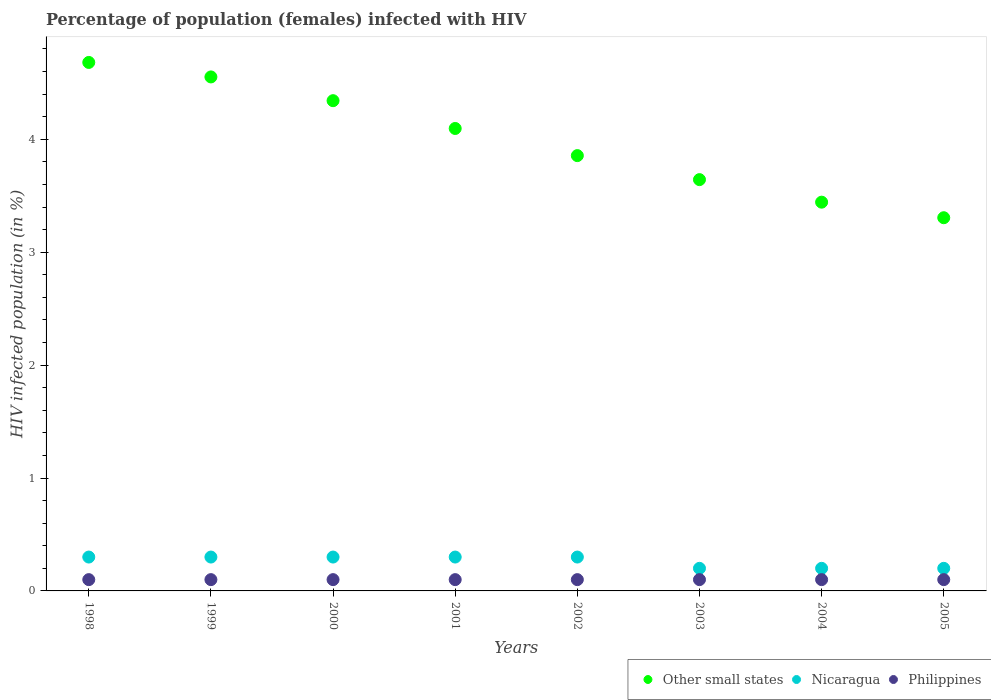Is the number of dotlines equal to the number of legend labels?
Make the answer very short. Yes. What is the percentage of HIV infected female population in Philippines in 2005?
Make the answer very short. 0.1. Across all years, what is the minimum percentage of HIV infected female population in Nicaragua?
Your response must be concise. 0.2. In which year was the percentage of HIV infected female population in Philippines maximum?
Keep it short and to the point. 1998. What is the total percentage of HIV infected female population in Other small states in the graph?
Give a very brief answer. 31.92. What is the difference between the percentage of HIV infected female population in Other small states in 2000 and that in 2003?
Provide a succinct answer. 0.7. What is the difference between the percentage of HIV infected female population in Other small states in 2004 and the percentage of HIV infected female population in Nicaragua in 2003?
Provide a short and direct response. 3.24. What is the average percentage of HIV infected female population in Philippines per year?
Provide a succinct answer. 0.1. In the year 2003, what is the difference between the percentage of HIV infected female population in Philippines and percentage of HIV infected female population in Nicaragua?
Provide a short and direct response. -0.1. What is the ratio of the percentage of HIV infected female population in Nicaragua in 1998 to that in 2003?
Offer a terse response. 1.5. What is the difference between the highest and the second highest percentage of HIV infected female population in Other small states?
Offer a very short reply. 0.13. What is the difference between the highest and the lowest percentage of HIV infected female population in Other small states?
Provide a short and direct response. 1.38. In how many years, is the percentage of HIV infected female population in Nicaragua greater than the average percentage of HIV infected female population in Nicaragua taken over all years?
Ensure brevity in your answer.  5. Is the sum of the percentage of HIV infected female population in Nicaragua in 1998 and 1999 greater than the maximum percentage of HIV infected female population in Philippines across all years?
Offer a terse response. Yes. Is it the case that in every year, the sum of the percentage of HIV infected female population in Philippines and percentage of HIV infected female population in Nicaragua  is greater than the percentage of HIV infected female population in Other small states?
Your answer should be compact. No. Is the percentage of HIV infected female population in Other small states strictly less than the percentage of HIV infected female population in Nicaragua over the years?
Keep it short and to the point. No. What is the difference between two consecutive major ticks on the Y-axis?
Provide a short and direct response. 1. Are the values on the major ticks of Y-axis written in scientific E-notation?
Give a very brief answer. No. Does the graph contain any zero values?
Keep it short and to the point. No. Does the graph contain grids?
Your response must be concise. No. Where does the legend appear in the graph?
Make the answer very short. Bottom right. How many legend labels are there?
Provide a short and direct response. 3. How are the legend labels stacked?
Keep it short and to the point. Horizontal. What is the title of the graph?
Offer a terse response. Percentage of population (females) infected with HIV. What is the label or title of the X-axis?
Keep it short and to the point. Years. What is the label or title of the Y-axis?
Offer a terse response. HIV infected population (in %). What is the HIV infected population (in %) in Other small states in 1998?
Offer a terse response. 4.68. What is the HIV infected population (in %) in Nicaragua in 1998?
Your answer should be very brief. 0.3. What is the HIV infected population (in %) in Other small states in 1999?
Your response must be concise. 4.55. What is the HIV infected population (in %) in Nicaragua in 1999?
Make the answer very short. 0.3. What is the HIV infected population (in %) in Philippines in 1999?
Provide a short and direct response. 0.1. What is the HIV infected population (in %) of Other small states in 2000?
Provide a short and direct response. 4.34. What is the HIV infected population (in %) of Other small states in 2001?
Your answer should be compact. 4.1. What is the HIV infected population (in %) in Other small states in 2002?
Make the answer very short. 3.86. What is the HIV infected population (in %) of Other small states in 2003?
Your answer should be compact. 3.64. What is the HIV infected population (in %) in Nicaragua in 2003?
Make the answer very short. 0.2. What is the HIV infected population (in %) of Philippines in 2003?
Your answer should be compact. 0.1. What is the HIV infected population (in %) of Other small states in 2004?
Ensure brevity in your answer.  3.44. What is the HIV infected population (in %) in Nicaragua in 2004?
Your response must be concise. 0.2. What is the HIV infected population (in %) in Philippines in 2004?
Keep it short and to the point. 0.1. What is the HIV infected population (in %) in Other small states in 2005?
Your answer should be very brief. 3.31. What is the HIV infected population (in %) in Nicaragua in 2005?
Provide a succinct answer. 0.2. Across all years, what is the maximum HIV infected population (in %) of Other small states?
Keep it short and to the point. 4.68. Across all years, what is the maximum HIV infected population (in %) in Nicaragua?
Give a very brief answer. 0.3. Across all years, what is the minimum HIV infected population (in %) in Other small states?
Ensure brevity in your answer.  3.31. What is the total HIV infected population (in %) of Other small states in the graph?
Keep it short and to the point. 31.92. What is the total HIV infected population (in %) in Nicaragua in the graph?
Your response must be concise. 2.1. What is the difference between the HIV infected population (in %) of Other small states in 1998 and that in 1999?
Offer a very short reply. 0.13. What is the difference between the HIV infected population (in %) in Nicaragua in 1998 and that in 1999?
Make the answer very short. 0. What is the difference between the HIV infected population (in %) of Philippines in 1998 and that in 1999?
Give a very brief answer. 0. What is the difference between the HIV infected population (in %) of Other small states in 1998 and that in 2000?
Your response must be concise. 0.34. What is the difference between the HIV infected population (in %) in Philippines in 1998 and that in 2000?
Provide a succinct answer. 0. What is the difference between the HIV infected population (in %) of Other small states in 1998 and that in 2001?
Offer a very short reply. 0.58. What is the difference between the HIV infected population (in %) in Other small states in 1998 and that in 2002?
Your answer should be compact. 0.83. What is the difference between the HIV infected population (in %) in Other small states in 1998 and that in 2003?
Keep it short and to the point. 1.04. What is the difference between the HIV infected population (in %) of Other small states in 1998 and that in 2004?
Keep it short and to the point. 1.24. What is the difference between the HIV infected population (in %) in Nicaragua in 1998 and that in 2004?
Provide a short and direct response. 0.1. What is the difference between the HIV infected population (in %) in Other small states in 1998 and that in 2005?
Ensure brevity in your answer.  1.38. What is the difference between the HIV infected population (in %) in Nicaragua in 1998 and that in 2005?
Give a very brief answer. 0.1. What is the difference between the HIV infected population (in %) in Other small states in 1999 and that in 2000?
Ensure brevity in your answer.  0.21. What is the difference between the HIV infected population (in %) of Nicaragua in 1999 and that in 2000?
Make the answer very short. 0. What is the difference between the HIV infected population (in %) in Other small states in 1999 and that in 2001?
Provide a succinct answer. 0.46. What is the difference between the HIV infected population (in %) in Philippines in 1999 and that in 2001?
Make the answer very short. 0. What is the difference between the HIV infected population (in %) in Other small states in 1999 and that in 2002?
Provide a short and direct response. 0.7. What is the difference between the HIV infected population (in %) in Nicaragua in 1999 and that in 2002?
Give a very brief answer. 0. What is the difference between the HIV infected population (in %) in Philippines in 1999 and that in 2002?
Your answer should be compact. 0. What is the difference between the HIV infected population (in %) of Other small states in 1999 and that in 2003?
Your response must be concise. 0.91. What is the difference between the HIV infected population (in %) of Nicaragua in 1999 and that in 2003?
Keep it short and to the point. 0.1. What is the difference between the HIV infected population (in %) of Other small states in 1999 and that in 2004?
Make the answer very short. 1.11. What is the difference between the HIV infected population (in %) of Philippines in 1999 and that in 2004?
Ensure brevity in your answer.  0. What is the difference between the HIV infected population (in %) in Other small states in 1999 and that in 2005?
Provide a short and direct response. 1.25. What is the difference between the HIV infected population (in %) in Nicaragua in 1999 and that in 2005?
Your response must be concise. 0.1. What is the difference between the HIV infected population (in %) in Other small states in 2000 and that in 2001?
Provide a succinct answer. 0.25. What is the difference between the HIV infected population (in %) in Nicaragua in 2000 and that in 2001?
Provide a succinct answer. 0. What is the difference between the HIV infected population (in %) in Other small states in 2000 and that in 2002?
Your answer should be very brief. 0.49. What is the difference between the HIV infected population (in %) of Other small states in 2000 and that in 2003?
Your response must be concise. 0.7. What is the difference between the HIV infected population (in %) in Nicaragua in 2000 and that in 2003?
Offer a very short reply. 0.1. What is the difference between the HIV infected population (in %) of Other small states in 2000 and that in 2004?
Make the answer very short. 0.9. What is the difference between the HIV infected population (in %) in Philippines in 2000 and that in 2004?
Provide a short and direct response. 0. What is the difference between the HIV infected population (in %) in Other small states in 2000 and that in 2005?
Offer a terse response. 1.04. What is the difference between the HIV infected population (in %) of Nicaragua in 2000 and that in 2005?
Ensure brevity in your answer.  0.1. What is the difference between the HIV infected population (in %) in Philippines in 2000 and that in 2005?
Provide a succinct answer. 0. What is the difference between the HIV infected population (in %) of Other small states in 2001 and that in 2002?
Your response must be concise. 0.24. What is the difference between the HIV infected population (in %) of Nicaragua in 2001 and that in 2002?
Keep it short and to the point. 0. What is the difference between the HIV infected population (in %) in Philippines in 2001 and that in 2002?
Provide a short and direct response. 0. What is the difference between the HIV infected population (in %) of Other small states in 2001 and that in 2003?
Keep it short and to the point. 0.45. What is the difference between the HIV infected population (in %) of Other small states in 2001 and that in 2004?
Give a very brief answer. 0.65. What is the difference between the HIV infected population (in %) of Nicaragua in 2001 and that in 2004?
Your response must be concise. 0.1. What is the difference between the HIV infected population (in %) in Philippines in 2001 and that in 2004?
Ensure brevity in your answer.  0. What is the difference between the HIV infected population (in %) in Other small states in 2001 and that in 2005?
Your answer should be very brief. 0.79. What is the difference between the HIV infected population (in %) of Nicaragua in 2001 and that in 2005?
Give a very brief answer. 0.1. What is the difference between the HIV infected population (in %) in Philippines in 2001 and that in 2005?
Make the answer very short. 0. What is the difference between the HIV infected population (in %) of Other small states in 2002 and that in 2003?
Ensure brevity in your answer.  0.21. What is the difference between the HIV infected population (in %) in Nicaragua in 2002 and that in 2003?
Offer a very short reply. 0.1. What is the difference between the HIV infected population (in %) in Other small states in 2002 and that in 2004?
Keep it short and to the point. 0.41. What is the difference between the HIV infected population (in %) in Philippines in 2002 and that in 2004?
Offer a very short reply. 0. What is the difference between the HIV infected population (in %) of Other small states in 2002 and that in 2005?
Provide a succinct answer. 0.55. What is the difference between the HIV infected population (in %) in Philippines in 2002 and that in 2005?
Your response must be concise. 0. What is the difference between the HIV infected population (in %) in Other small states in 2003 and that in 2004?
Ensure brevity in your answer.  0.2. What is the difference between the HIV infected population (in %) in Nicaragua in 2003 and that in 2004?
Keep it short and to the point. 0. What is the difference between the HIV infected population (in %) in Other small states in 2003 and that in 2005?
Offer a very short reply. 0.34. What is the difference between the HIV infected population (in %) of Philippines in 2003 and that in 2005?
Your answer should be compact. 0. What is the difference between the HIV infected population (in %) of Other small states in 2004 and that in 2005?
Provide a succinct answer. 0.14. What is the difference between the HIV infected population (in %) of Nicaragua in 2004 and that in 2005?
Your answer should be very brief. 0. What is the difference between the HIV infected population (in %) in Other small states in 1998 and the HIV infected population (in %) in Nicaragua in 1999?
Your response must be concise. 4.38. What is the difference between the HIV infected population (in %) in Other small states in 1998 and the HIV infected population (in %) in Philippines in 1999?
Offer a very short reply. 4.58. What is the difference between the HIV infected population (in %) in Nicaragua in 1998 and the HIV infected population (in %) in Philippines in 1999?
Your answer should be compact. 0.2. What is the difference between the HIV infected population (in %) of Other small states in 1998 and the HIV infected population (in %) of Nicaragua in 2000?
Your response must be concise. 4.38. What is the difference between the HIV infected population (in %) of Other small states in 1998 and the HIV infected population (in %) of Philippines in 2000?
Provide a short and direct response. 4.58. What is the difference between the HIV infected population (in %) in Other small states in 1998 and the HIV infected population (in %) in Nicaragua in 2001?
Provide a short and direct response. 4.38. What is the difference between the HIV infected population (in %) in Other small states in 1998 and the HIV infected population (in %) in Philippines in 2001?
Offer a very short reply. 4.58. What is the difference between the HIV infected population (in %) of Other small states in 1998 and the HIV infected population (in %) of Nicaragua in 2002?
Provide a succinct answer. 4.38. What is the difference between the HIV infected population (in %) in Other small states in 1998 and the HIV infected population (in %) in Philippines in 2002?
Keep it short and to the point. 4.58. What is the difference between the HIV infected population (in %) of Nicaragua in 1998 and the HIV infected population (in %) of Philippines in 2002?
Keep it short and to the point. 0.2. What is the difference between the HIV infected population (in %) in Other small states in 1998 and the HIV infected population (in %) in Nicaragua in 2003?
Keep it short and to the point. 4.48. What is the difference between the HIV infected population (in %) in Other small states in 1998 and the HIV infected population (in %) in Philippines in 2003?
Your response must be concise. 4.58. What is the difference between the HIV infected population (in %) in Nicaragua in 1998 and the HIV infected population (in %) in Philippines in 2003?
Your answer should be compact. 0.2. What is the difference between the HIV infected population (in %) of Other small states in 1998 and the HIV infected population (in %) of Nicaragua in 2004?
Ensure brevity in your answer.  4.48. What is the difference between the HIV infected population (in %) in Other small states in 1998 and the HIV infected population (in %) in Philippines in 2004?
Keep it short and to the point. 4.58. What is the difference between the HIV infected population (in %) of Nicaragua in 1998 and the HIV infected population (in %) of Philippines in 2004?
Your answer should be compact. 0.2. What is the difference between the HIV infected population (in %) in Other small states in 1998 and the HIV infected population (in %) in Nicaragua in 2005?
Your answer should be very brief. 4.48. What is the difference between the HIV infected population (in %) of Other small states in 1998 and the HIV infected population (in %) of Philippines in 2005?
Offer a terse response. 4.58. What is the difference between the HIV infected population (in %) in Nicaragua in 1998 and the HIV infected population (in %) in Philippines in 2005?
Make the answer very short. 0.2. What is the difference between the HIV infected population (in %) in Other small states in 1999 and the HIV infected population (in %) in Nicaragua in 2000?
Provide a short and direct response. 4.25. What is the difference between the HIV infected population (in %) of Other small states in 1999 and the HIV infected population (in %) of Philippines in 2000?
Offer a terse response. 4.45. What is the difference between the HIV infected population (in %) of Nicaragua in 1999 and the HIV infected population (in %) of Philippines in 2000?
Keep it short and to the point. 0.2. What is the difference between the HIV infected population (in %) of Other small states in 1999 and the HIV infected population (in %) of Nicaragua in 2001?
Offer a terse response. 4.25. What is the difference between the HIV infected population (in %) of Other small states in 1999 and the HIV infected population (in %) of Philippines in 2001?
Provide a short and direct response. 4.45. What is the difference between the HIV infected population (in %) in Other small states in 1999 and the HIV infected population (in %) in Nicaragua in 2002?
Keep it short and to the point. 4.25. What is the difference between the HIV infected population (in %) in Other small states in 1999 and the HIV infected population (in %) in Philippines in 2002?
Offer a very short reply. 4.45. What is the difference between the HIV infected population (in %) in Nicaragua in 1999 and the HIV infected population (in %) in Philippines in 2002?
Ensure brevity in your answer.  0.2. What is the difference between the HIV infected population (in %) of Other small states in 1999 and the HIV infected population (in %) of Nicaragua in 2003?
Provide a succinct answer. 4.35. What is the difference between the HIV infected population (in %) of Other small states in 1999 and the HIV infected population (in %) of Philippines in 2003?
Your response must be concise. 4.45. What is the difference between the HIV infected population (in %) in Nicaragua in 1999 and the HIV infected population (in %) in Philippines in 2003?
Offer a very short reply. 0.2. What is the difference between the HIV infected population (in %) in Other small states in 1999 and the HIV infected population (in %) in Nicaragua in 2004?
Your answer should be very brief. 4.35. What is the difference between the HIV infected population (in %) of Other small states in 1999 and the HIV infected population (in %) of Philippines in 2004?
Your answer should be very brief. 4.45. What is the difference between the HIV infected population (in %) in Other small states in 1999 and the HIV infected population (in %) in Nicaragua in 2005?
Offer a very short reply. 4.35. What is the difference between the HIV infected population (in %) in Other small states in 1999 and the HIV infected population (in %) in Philippines in 2005?
Offer a terse response. 4.45. What is the difference between the HIV infected population (in %) of Other small states in 2000 and the HIV infected population (in %) of Nicaragua in 2001?
Your response must be concise. 4.04. What is the difference between the HIV infected population (in %) in Other small states in 2000 and the HIV infected population (in %) in Philippines in 2001?
Offer a terse response. 4.24. What is the difference between the HIV infected population (in %) of Other small states in 2000 and the HIV infected population (in %) of Nicaragua in 2002?
Provide a short and direct response. 4.04. What is the difference between the HIV infected population (in %) in Other small states in 2000 and the HIV infected population (in %) in Philippines in 2002?
Make the answer very short. 4.24. What is the difference between the HIV infected population (in %) in Other small states in 2000 and the HIV infected population (in %) in Nicaragua in 2003?
Offer a very short reply. 4.14. What is the difference between the HIV infected population (in %) of Other small states in 2000 and the HIV infected population (in %) of Philippines in 2003?
Your response must be concise. 4.24. What is the difference between the HIV infected population (in %) in Nicaragua in 2000 and the HIV infected population (in %) in Philippines in 2003?
Offer a very short reply. 0.2. What is the difference between the HIV infected population (in %) of Other small states in 2000 and the HIV infected population (in %) of Nicaragua in 2004?
Your answer should be very brief. 4.14. What is the difference between the HIV infected population (in %) of Other small states in 2000 and the HIV infected population (in %) of Philippines in 2004?
Your response must be concise. 4.24. What is the difference between the HIV infected population (in %) of Other small states in 2000 and the HIV infected population (in %) of Nicaragua in 2005?
Ensure brevity in your answer.  4.14. What is the difference between the HIV infected population (in %) in Other small states in 2000 and the HIV infected population (in %) in Philippines in 2005?
Give a very brief answer. 4.24. What is the difference between the HIV infected population (in %) of Nicaragua in 2000 and the HIV infected population (in %) of Philippines in 2005?
Provide a short and direct response. 0.2. What is the difference between the HIV infected population (in %) in Other small states in 2001 and the HIV infected population (in %) in Nicaragua in 2002?
Provide a succinct answer. 3.8. What is the difference between the HIV infected population (in %) in Other small states in 2001 and the HIV infected population (in %) in Philippines in 2002?
Your response must be concise. 4. What is the difference between the HIV infected population (in %) of Nicaragua in 2001 and the HIV infected population (in %) of Philippines in 2002?
Ensure brevity in your answer.  0.2. What is the difference between the HIV infected population (in %) in Other small states in 2001 and the HIV infected population (in %) in Nicaragua in 2003?
Provide a short and direct response. 3.9. What is the difference between the HIV infected population (in %) in Other small states in 2001 and the HIV infected population (in %) in Philippines in 2003?
Make the answer very short. 4. What is the difference between the HIV infected population (in %) of Other small states in 2001 and the HIV infected population (in %) of Nicaragua in 2004?
Your answer should be compact. 3.9. What is the difference between the HIV infected population (in %) in Other small states in 2001 and the HIV infected population (in %) in Philippines in 2004?
Offer a very short reply. 4. What is the difference between the HIV infected population (in %) of Other small states in 2001 and the HIV infected population (in %) of Nicaragua in 2005?
Make the answer very short. 3.9. What is the difference between the HIV infected population (in %) in Other small states in 2001 and the HIV infected population (in %) in Philippines in 2005?
Make the answer very short. 4. What is the difference between the HIV infected population (in %) in Other small states in 2002 and the HIV infected population (in %) in Nicaragua in 2003?
Provide a short and direct response. 3.66. What is the difference between the HIV infected population (in %) in Other small states in 2002 and the HIV infected population (in %) in Philippines in 2003?
Offer a very short reply. 3.76. What is the difference between the HIV infected population (in %) in Nicaragua in 2002 and the HIV infected population (in %) in Philippines in 2003?
Provide a succinct answer. 0.2. What is the difference between the HIV infected population (in %) of Other small states in 2002 and the HIV infected population (in %) of Nicaragua in 2004?
Give a very brief answer. 3.66. What is the difference between the HIV infected population (in %) in Other small states in 2002 and the HIV infected population (in %) in Philippines in 2004?
Make the answer very short. 3.76. What is the difference between the HIV infected population (in %) of Nicaragua in 2002 and the HIV infected population (in %) of Philippines in 2004?
Ensure brevity in your answer.  0.2. What is the difference between the HIV infected population (in %) in Other small states in 2002 and the HIV infected population (in %) in Nicaragua in 2005?
Provide a succinct answer. 3.66. What is the difference between the HIV infected population (in %) in Other small states in 2002 and the HIV infected population (in %) in Philippines in 2005?
Your answer should be very brief. 3.76. What is the difference between the HIV infected population (in %) in Other small states in 2003 and the HIV infected population (in %) in Nicaragua in 2004?
Your answer should be compact. 3.44. What is the difference between the HIV infected population (in %) in Other small states in 2003 and the HIV infected population (in %) in Philippines in 2004?
Provide a short and direct response. 3.54. What is the difference between the HIV infected population (in %) of Other small states in 2003 and the HIV infected population (in %) of Nicaragua in 2005?
Ensure brevity in your answer.  3.44. What is the difference between the HIV infected population (in %) of Other small states in 2003 and the HIV infected population (in %) of Philippines in 2005?
Your answer should be compact. 3.54. What is the difference between the HIV infected population (in %) of Other small states in 2004 and the HIV infected population (in %) of Nicaragua in 2005?
Ensure brevity in your answer.  3.24. What is the difference between the HIV infected population (in %) in Other small states in 2004 and the HIV infected population (in %) in Philippines in 2005?
Offer a very short reply. 3.34. What is the difference between the HIV infected population (in %) of Nicaragua in 2004 and the HIV infected population (in %) of Philippines in 2005?
Your answer should be compact. 0.1. What is the average HIV infected population (in %) of Other small states per year?
Provide a succinct answer. 3.99. What is the average HIV infected population (in %) in Nicaragua per year?
Your answer should be very brief. 0.26. In the year 1998, what is the difference between the HIV infected population (in %) in Other small states and HIV infected population (in %) in Nicaragua?
Your answer should be very brief. 4.38. In the year 1998, what is the difference between the HIV infected population (in %) of Other small states and HIV infected population (in %) of Philippines?
Provide a succinct answer. 4.58. In the year 1998, what is the difference between the HIV infected population (in %) of Nicaragua and HIV infected population (in %) of Philippines?
Your response must be concise. 0.2. In the year 1999, what is the difference between the HIV infected population (in %) in Other small states and HIV infected population (in %) in Nicaragua?
Give a very brief answer. 4.25. In the year 1999, what is the difference between the HIV infected population (in %) in Other small states and HIV infected population (in %) in Philippines?
Offer a terse response. 4.45. In the year 2000, what is the difference between the HIV infected population (in %) in Other small states and HIV infected population (in %) in Nicaragua?
Give a very brief answer. 4.04. In the year 2000, what is the difference between the HIV infected population (in %) in Other small states and HIV infected population (in %) in Philippines?
Give a very brief answer. 4.24. In the year 2001, what is the difference between the HIV infected population (in %) in Other small states and HIV infected population (in %) in Nicaragua?
Offer a terse response. 3.8. In the year 2001, what is the difference between the HIV infected population (in %) of Other small states and HIV infected population (in %) of Philippines?
Provide a succinct answer. 4. In the year 2002, what is the difference between the HIV infected population (in %) in Other small states and HIV infected population (in %) in Nicaragua?
Your answer should be very brief. 3.56. In the year 2002, what is the difference between the HIV infected population (in %) in Other small states and HIV infected population (in %) in Philippines?
Offer a very short reply. 3.76. In the year 2002, what is the difference between the HIV infected population (in %) of Nicaragua and HIV infected population (in %) of Philippines?
Offer a terse response. 0.2. In the year 2003, what is the difference between the HIV infected population (in %) of Other small states and HIV infected population (in %) of Nicaragua?
Your answer should be very brief. 3.44. In the year 2003, what is the difference between the HIV infected population (in %) in Other small states and HIV infected population (in %) in Philippines?
Your answer should be very brief. 3.54. In the year 2004, what is the difference between the HIV infected population (in %) of Other small states and HIV infected population (in %) of Nicaragua?
Keep it short and to the point. 3.24. In the year 2004, what is the difference between the HIV infected population (in %) in Other small states and HIV infected population (in %) in Philippines?
Your answer should be compact. 3.34. In the year 2005, what is the difference between the HIV infected population (in %) of Other small states and HIV infected population (in %) of Nicaragua?
Your response must be concise. 3.11. In the year 2005, what is the difference between the HIV infected population (in %) of Other small states and HIV infected population (in %) of Philippines?
Keep it short and to the point. 3.21. In the year 2005, what is the difference between the HIV infected population (in %) of Nicaragua and HIV infected population (in %) of Philippines?
Make the answer very short. 0.1. What is the ratio of the HIV infected population (in %) in Other small states in 1998 to that in 1999?
Your answer should be compact. 1.03. What is the ratio of the HIV infected population (in %) of Nicaragua in 1998 to that in 1999?
Keep it short and to the point. 1. What is the ratio of the HIV infected population (in %) of Philippines in 1998 to that in 1999?
Your answer should be very brief. 1. What is the ratio of the HIV infected population (in %) of Other small states in 1998 to that in 2000?
Make the answer very short. 1.08. What is the ratio of the HIV infected population (in %) in Nicaragua in 1998 to that in 2000?
Your response must be concise. 1. What is the ratio of the HIV infected population (in %) of Other small states in 1998 to that in 2001?
Offer a very short reply. 1.14. What is the ratio of the HIV infected population (in %) in Nicaragua in 1998 to that in 2001?
Your response must be concise. 1. What is the ratio of the HIV infected population (in %) of Philippines in 1998 to that in 2001?
Your answer should be very brief. 1. What is the ratio of the HIV infected population (in %) in Other small states in 1998 to that in 2002?
Your response must be concise. 1.21. What is the ratio of the HIV infected population (in %) in Philippines in 1998 to that in 2002?
Provide a short and direct response. 1. What is the ratio of the HIV infected population (in %) of Other small states in 1998 to that in 2003?
Your answer should be very brief. 1.28. What is the ratio of the HIV infected population (in %) of Other small states in 1998 to that in 2004?
Provide a succinct answer. 1.36. What is the ratio of the HIV infected population (in %) of Nicaragua in 1998 to that in 2004?
Keep it short and to the point. 1.5. What is the ratio of the HIV infected population (in %) of Philippines in 1998 to that in 2004?
Offer a very short reply. 1. What is the ratio of the HIV infected population (in %) of Other small states in 1998 to that in 2005?
Your response must be concise. 1.42. What is the ratio of the HIV infected population (in %) of Nicaragua in 1998 to that in 2005?
Provide a succinct answer. 1.5. What is the ratio of the HIV infected population (in %) of Philippines in 1998 to that in 2005?
Provide a succinct answer. 1. What is the ratio of the HIV infected population (in %) in Other small states in 1999 to that in 2000?
Give a very brief answer. 1.05. What is the ratio of the HIV infected population (in %) of Nicaragua in 1999 to that in 2000?
Give a very brief answer. 1. What is the ratio of the HIV infected population (in %) of Other small states in 1999 to that in 2001?
Provide a short and direct response. 1.11. What is the ratio of the HIV infected population (in %) in Nicaragua in 1999 to that in 2001?
Your answer should be compact. 1. What is the ratio of the HIV infected population (in %) in Philippines in 1999 to that in 2001?
Ensure brevity in your answer.  1. What is the ratio of the HIV infected population (in %) in Other small states in 1999 to that in 2002?
Give a very brief answer. 1.18. What is the ratio of the HIV infected population (in %) in Philippines in 1999 to that in 2002?
Provide a succinct answer. 1. What is the ratio of the HIV infected population (in %) in Other small states in 1999 to that in 2003?
Ensure brevity in your answer.  1.25. What is the ratio of the HIV infected population (in %) in Philippines in 1999 to that in 2003?
Give a very brief answer. 1. What is the ratio of the HIV infected population (in %) of Other small states in 1999 to that in 2004?
Keep it short and to the point. 1.32. What is the ratio of the HIV infected population (in %) in Philippines in 1999 to that in 2004?
Ensure brevity in your answer.  1. What is the ratio of the HIV infected population (in %) of Other small states in 1999 to that in 2005?
Provide a short and direct response. 1.38. What is the ratio of the HIV infected population (in %) in Nicaragua in 1999 to that in 2005?
Give a very brief answer. 1.5. What is the ratio of the HIV infected population (in %) in Philippines in 1999 to that in 2005?
Provide a succinct answer. 1. What is the ratio of the HIV infected population (in %) in Other small states in 2000 to that in 2001?
Your response must be concise. 1.06. What is the ratio of the HIV infected population (in %) in Nicaragua in 2000 to that in 2001?
Give a very brief answer. 1. What is the ratio of the HIV infected population (in %) in Philippines in 2000 to that in 2001?
Make the answer very short. 1. What is the ratio of the HIV infected population (in %) of Other small states in 2000 to that in 2002?
Your answer should be compact. 1.13. What is the ratio of the HIV infected population (in %) in Nicaragua in 2000 to that in 2002?
Keep it short and to the point. 1. What is the ratio of the HIV infected population (in %) in Philippines in 2000 to that in 2002?
Provide a succinct answer. 1. What is the ratio of the HIV infected population (in %) of Other small states in 2000 to that in 2003?
Provide a succinct answer. 1.19. What is the ratio of the HIV infected population (in %) in Philippines in 2000 to that in 2003?
Keep it short and to the point. 1. What is the ratio of the HIV infected population (in %) of Other small states in 2000 to that in 2004?
Keep it short and to the point. 1.26. What is the ratio of the HIV infected population (in %) of Nicaragua in 2000 to that in 2004?
Offer a very short reply. 1.5. What is the ratio of the HIV infected population (in %) in Philippines in 2000 to that in 2004?
Make the answer very short. 1. What is the ratio of the HIV infected population (in %) of Other small states in 2000 to that in 2005?
Your answer should be very brief. 1.31. What is the ratio of the HIV infected population (in %) in Nicaragua in 2000 to that in 2005?
Give a very brief answer. 1.5. What is the ratio of the HIV infected population (in %) of Philippines in 2000 to that in 2005?
Make the answer very short. 1. What is the ratio of the HIV infected population (in %) in Other small states in 2001 to that in 2002?
Ensure brevity in your answer.  1.06. What is the ratio of the HIV infected population (in %) of Nicaragua in 2001 to that in 2002?
Offer a terse response. 1. What is the ratio of the HIV infected population (in %) of Other small states in 2001 to that in 2003?
Your answer should be compact. 1.12. What is the ratio of the HIV infected population (in %) of Nicaragua in 2001 to that in 2003?
Your response must be concise. 1.5. What is the ratio of the HIV infected population (in %) of Other small states in 2001 to that in 2004?
Your answer should be very brief. 1.19. What is the ratio of the HIV infected population (in %) in Philippines in 2001 to that in 2004?
Your answer should be compact. 1. What is the ratio of the HIV infected population (in %) of Other small states in 2001 to that in 2005?
Make the answer very short. 1.24. What is the ratio of the HIV infected population (in %) in Nicaragua in 2001 to that in 2005?
Provide a succinct answer. 1.5. What is the ratio of the HIV infected population (in %) of Philippines in 2001 to that in 2005?
Give a very brief answer. 1. What is the ratio of the HIV infected population (in %) in Other small states in 2002 to that in 2003?
Your answer should be compact. 1.06. What is the ratio of the HIV infected population (in %) in Nicaragua in 2002 to that in 2003?
Offer a very short reply. 1.5. What is the ratio of the HIV infected population (in %) of Philippines in 2002 to that in 2003?
Your response must be concise. 1. What is the ratio of the HIV infected population (in %) in Other small states in 2002 to that in 2004?
Make the answer very short. 1.12. What is the ratio of the HIV infected population (in %) of Philippines in 2002 to that in 2004?
Give a very brief answer. 1. What is the ratio of the HIV infected population (in %) of Other small states in 2002 to that in 2005?
Keep it short and to the point. 1.17. What is the ratio of the HIV infected population (in %) of Philippines in 2002 to that in 2005?
Ensure brevity in your answer.  1. What is the ratio of the HIV infected population (in %) in Other small states in 2003 to that in 2004?
Your answer should be very brief. 1.06. What is the ratio of the HIV infected population (in %) of Nicaragua in 2003 to that in 2004?
Give a very brief answer. 1. What is the ratio of the HIV infected population (in %) of Other small states in 2003 to that in 2005?
Provide a succinct answer. 1.1. What is the ratio of the HIV infected population (in %) of Nicaragua in 2003 to that in 2005?
Offer a terse response. 1. What is the ratio of the HIV infected population (in %) in Other small states in 2004 to that in 2005?
Keep it short and to the point. 1.04. What is the ratio of the HIV infected population (in %) of Nicaragua in 2004 to that in 2005?
Provide a succinct answer. 1. What is the ratio of the HIV infected population (in %) in Philippines in 2004 to that in 2005?
Provide a succinct answer. 1. What is the difference between the highest and the second highest HIV infected population (in %) in Other small states?
Provide a short and direct response. 0.13. What is the difference between the highest and the second highest HIV infected population (in %) of Philippines?
Provide a succinct answer. 0. What is the difference between the highest and the lowest HIV infected population (in %) in Other small states?
Offer a very short reply. 1.38. 